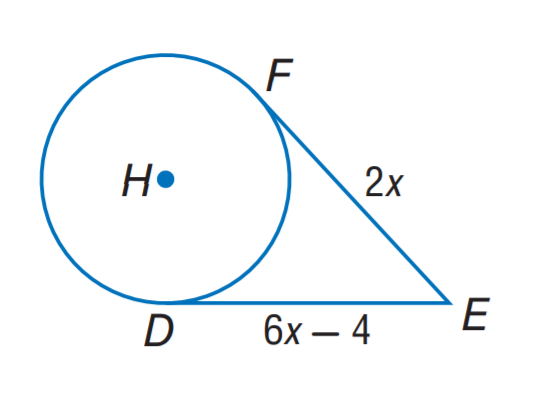Answer the mathemtical geometry problem and directly provide the correct option letter.
Question: The segment is tangent to the circle. Find x.
Choices: A: 1 B: 2 C: 3 D: 4 A 